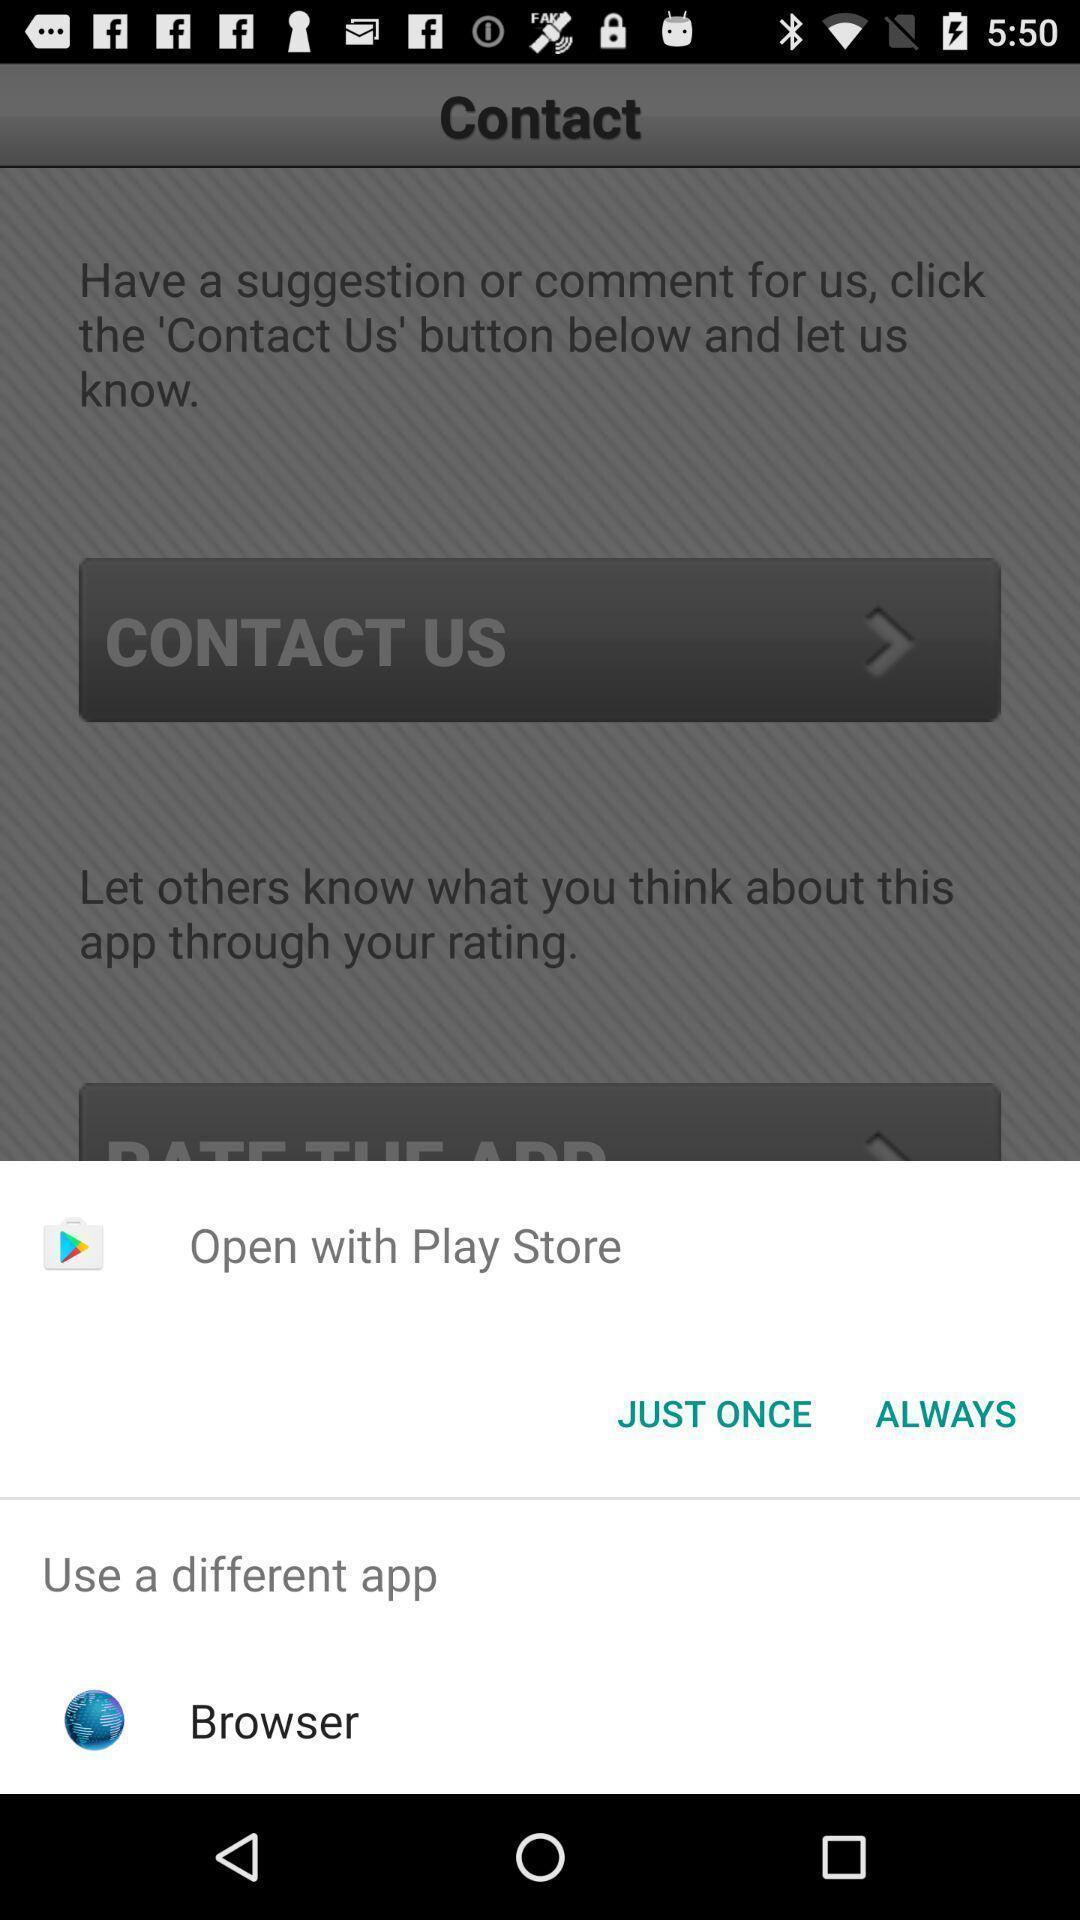Provide a description of this screenshot. Pop-up showing options to open a browser. 